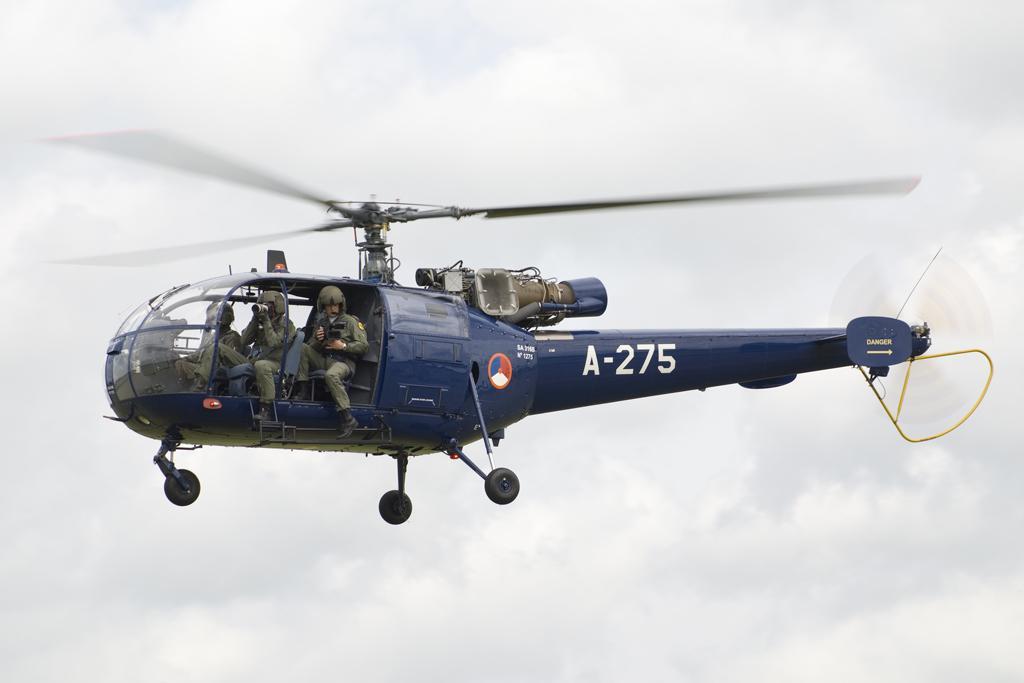Please provide a concise description of this image. In the image we can see a helicopter. In the helicopter there are people sitting, they are wearing clothes, helmet and shoes. And a cloudy sky. 